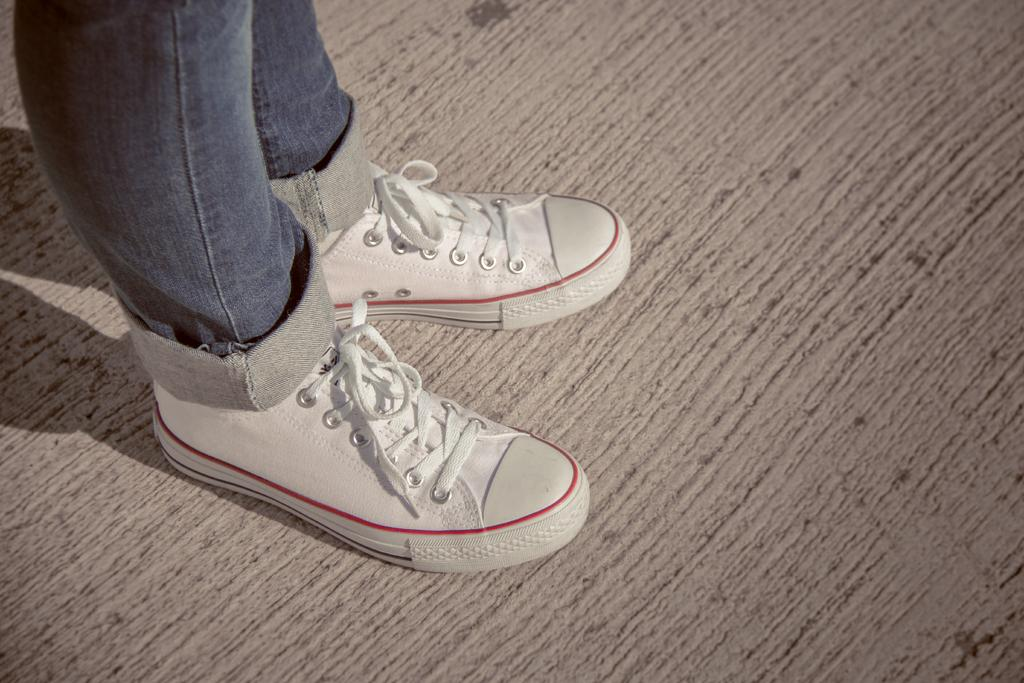What part of the person's body can be seen in the image? The person's legs are visible in the image. What is the person wearing in the image? The person is wearing a blue dress and shoes. What color is the surface the person is standing on? The person is standing on a brown color surface. How many oranges are visible in the image? There are no oranges present in the image. What type of park can be seen in the background of the image? There is no park visible in the image; it only shows the person's legs, clothing, and the surface they are standing on. 